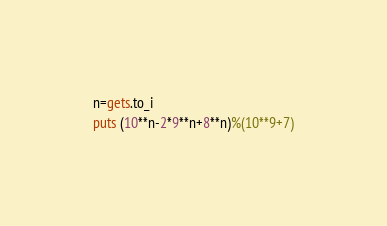Convert code to text. <code><loc_0><loc_0><loc_500><loc_500><_Ruby_>n=gets.to_i
puts (10**n-2*9**n+8**n)%(10**9+7)
</code> 